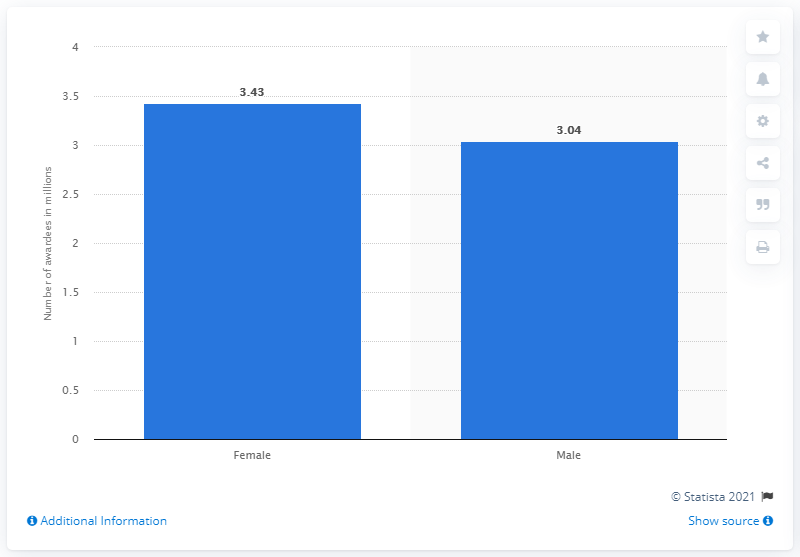Give some essential details in this illustration. During the academic year of 2019, a total of 3.43 female students were awarded their undergraduate degree. 